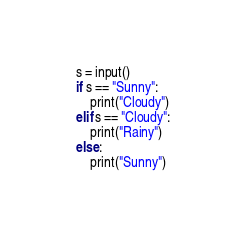Convert code to text. <code><loc_0><loc_0><loc_500><loc_500><_Python_>s = input()
if s == "Sunny":
    print("Cloudy")
elif s == "Cloudy":
    print("Rainy")
else:
    print("Sunny")</code> 